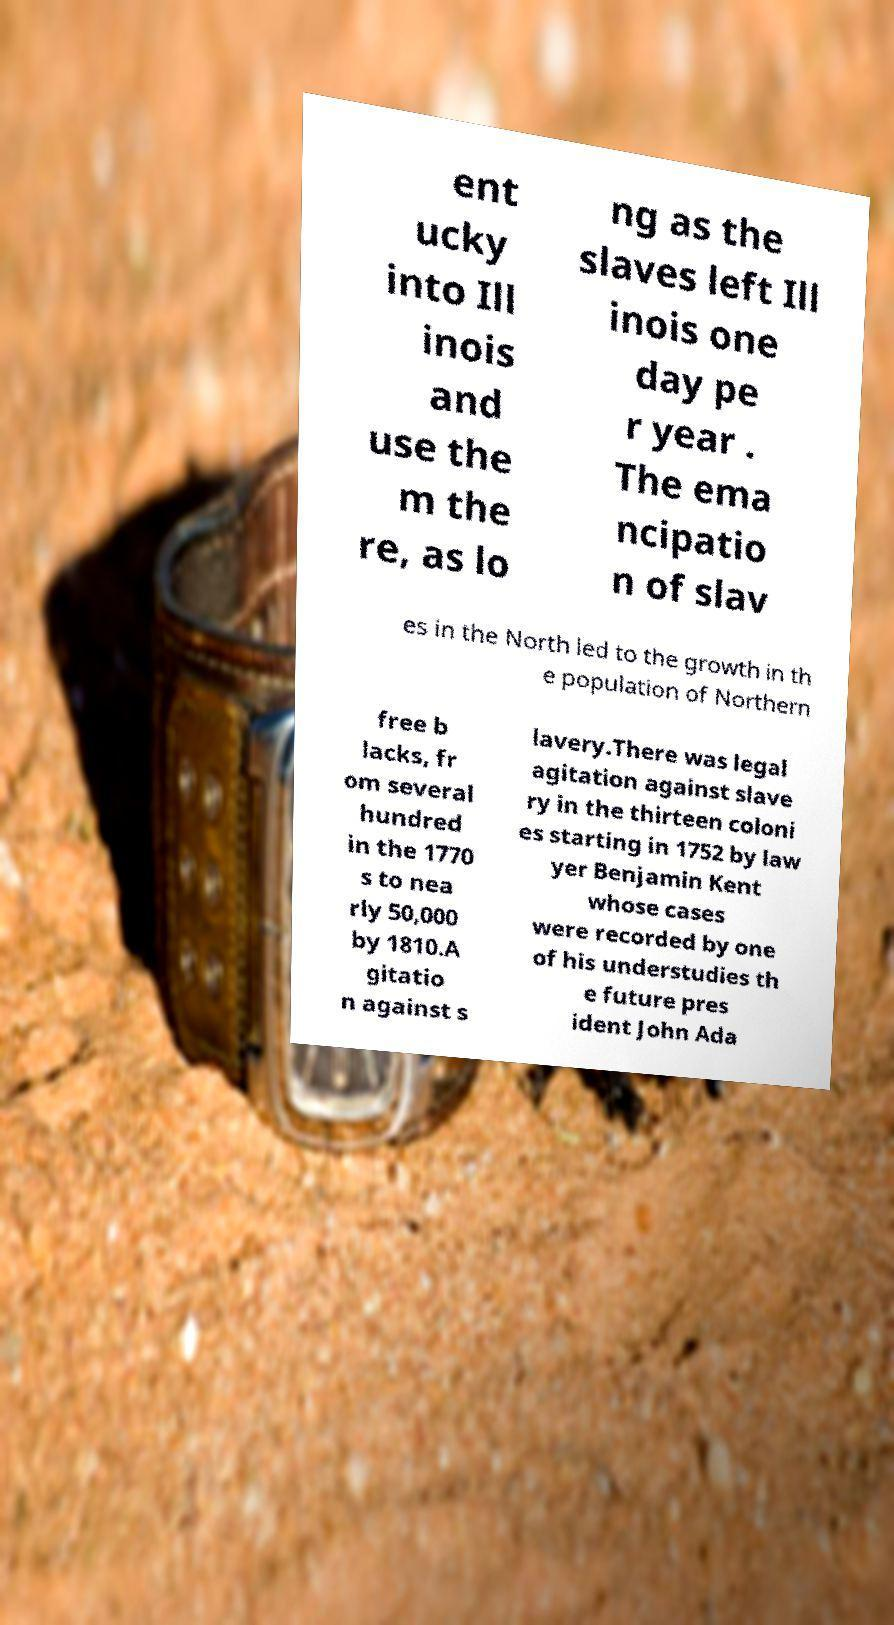Can you accurately transcribe the text from the provided image for me? ent ucky into Ill inois and use the m the re, as lo ng as the slaves left Ill inois one day pe r year . The ema ncipatio n of slav es in the North led to the growth in th e population of Northern free b lacks, fr om several hundred in the 1770 s to nea rly 50,000 by 1810.A gitatio n against s lavery.There was legal agitation against slave ry in the thirteen coloni es starting in 1752 by law yer Benjamin Kent whose cases were recorded by one of his understudies th e future pres ident John Ada 